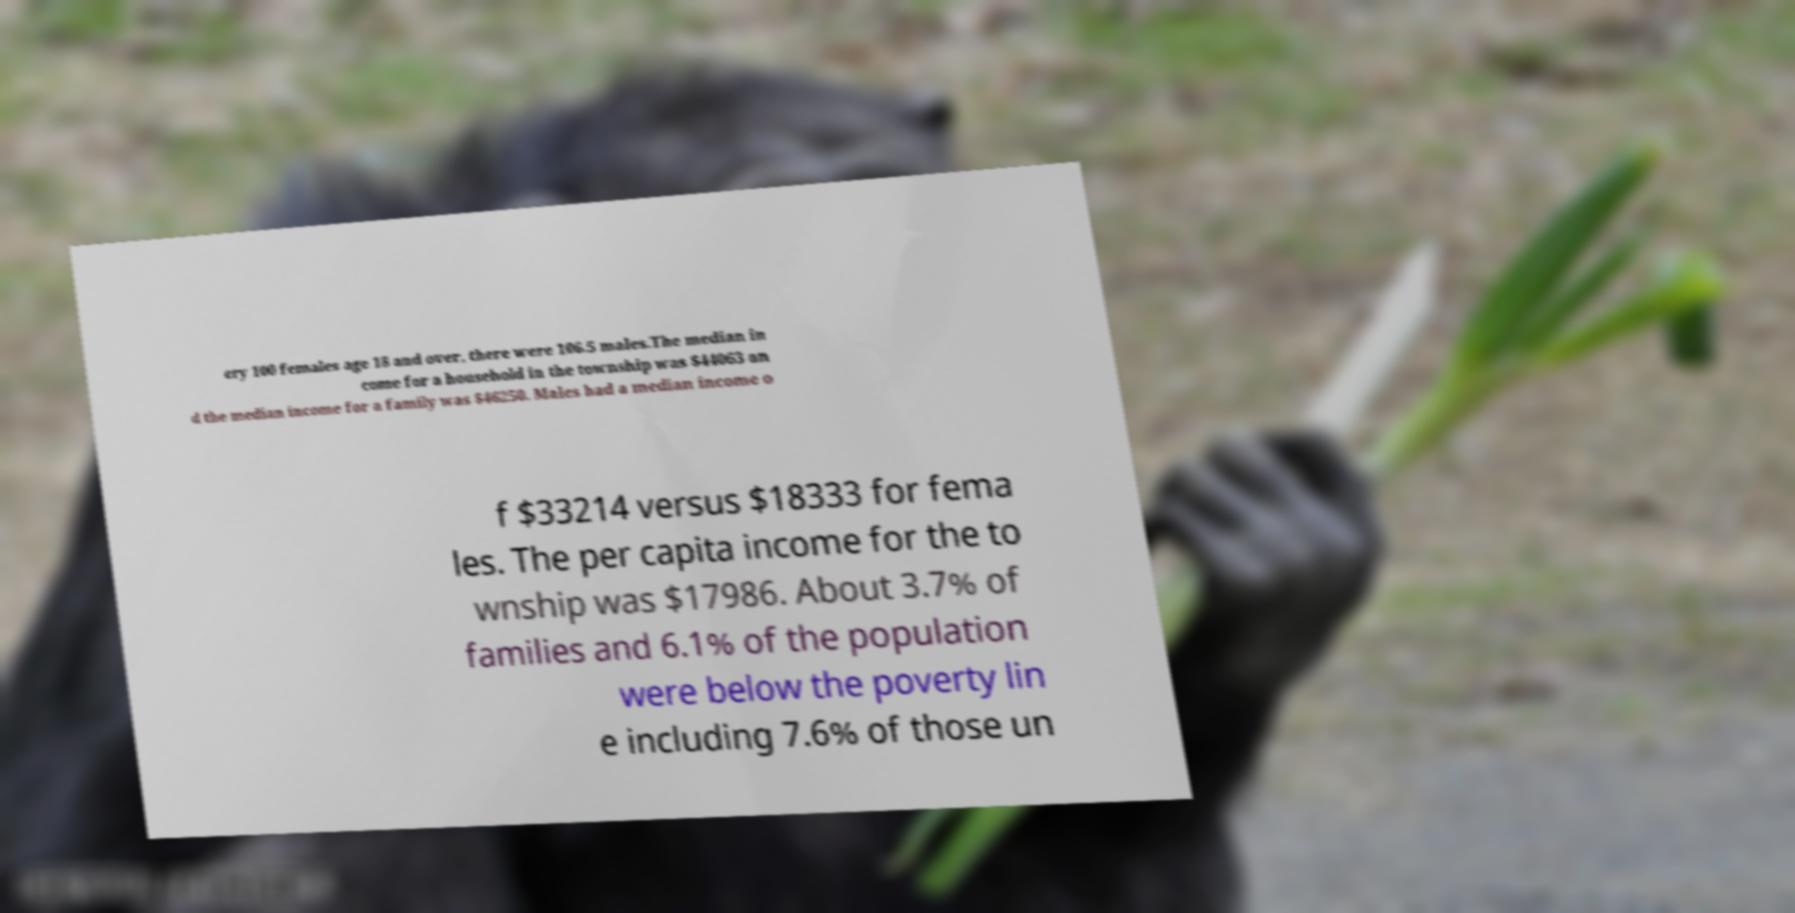Can you read and provide the text displayed in the image?This photo seems to have some interesting text. Can you extract and type it out for me? ery 100 females age 18 and over, there were 106.5 males.The median in come for a household in the township was $44063 an d the median income for a family was $46250. Males had a median income o f $33214 versus $18333 for fema les. The per capita income for the to wnship was $17986. About 3.7% of families and 6.1% of the population were below the poverty lin e including 7.6% of those un 